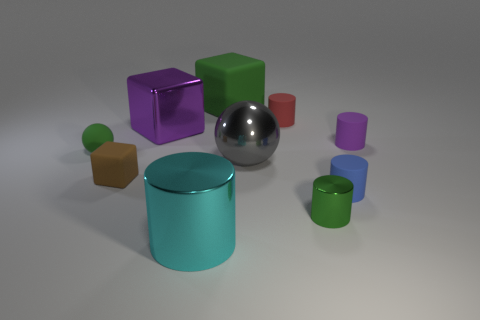There is a purple object that is the same shape as the large cyan shiny thing; what is it made of?
Make the answer very short. Rubber. How many blue cylinders have the same size as the green metallic object?
Provide a succinct answer. 1. Is there a tiny purple cylinder that is behind the small object that is left of the brown matte block?
Your answer should be compact. Yes. How many yellow objects are balls or big shiny things?
Keep it short and to the point. 0. The big sphere is what color?
Your response must be concise. Gray. There is a brown block that is made of the same material as the small red cylinder; what size is it?
Keep it short and to the point. Small. How many tiny purple rubber objects are the same shape as the brown object?
Ensure brevity in your answer.  0. Are there any other things that have the same size as the blue cylinder?
Make the answer very short. Yes. There is a purple object to the left of the large metallic object that is in front of the small shiny thing; how big is it?
Offer a terse response. Large. There is a red object that is the same size as the green shiny cylinder; what material is it?
Keep it short and to the point. Rubber. 